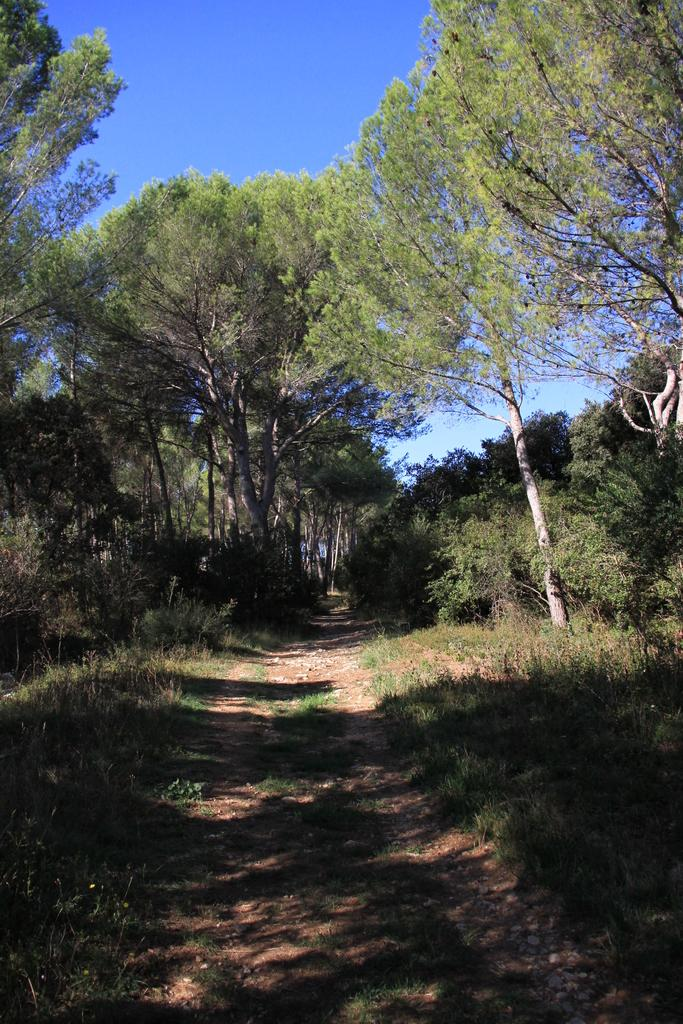What is located at the bottom of the image? There is a way at the bottom of the image. What can be seen on either side of the way? There are trees on either side of the way. What is visible at the top of the image? The sky is visible at the top of the image. What is the color of the sky in the image? The color of the sky is blue. Where is the ant located in the image? There is no ant present in the image. What type of zipper can be seen on the trees in the image? There are no zippers present on the trees in the image. 